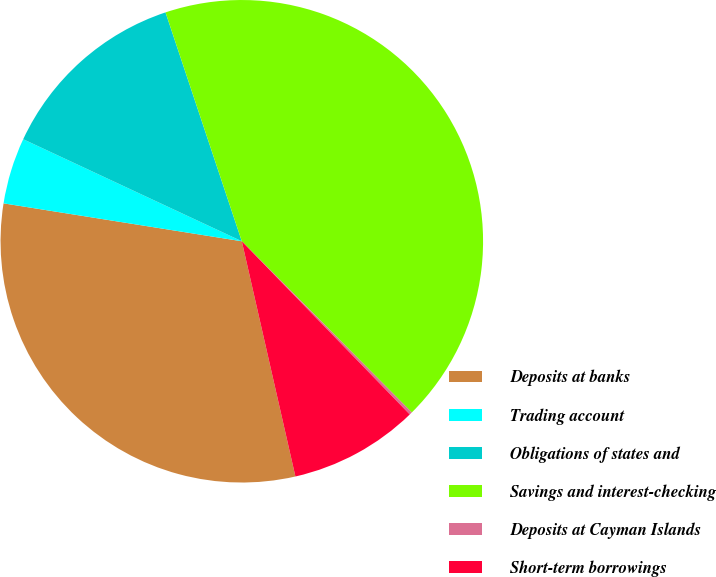Convert chart to OTSL. <chart><loc_0><loc_0><loc_500><loc_500><pie_chart><fcel>Deposits at banks<fcel>Trading account<fcel>Obligations of states and<fcel>Savings and interest-checking<fcel>Deposits at Cayman Islands<fcel>Short-term borrowings<nl><fcel>31.08%<fcel>4.44%<fcel>12.93%<fcel>42.68%<fcel>0.19%<fcel>8.69%<nl></chart> 